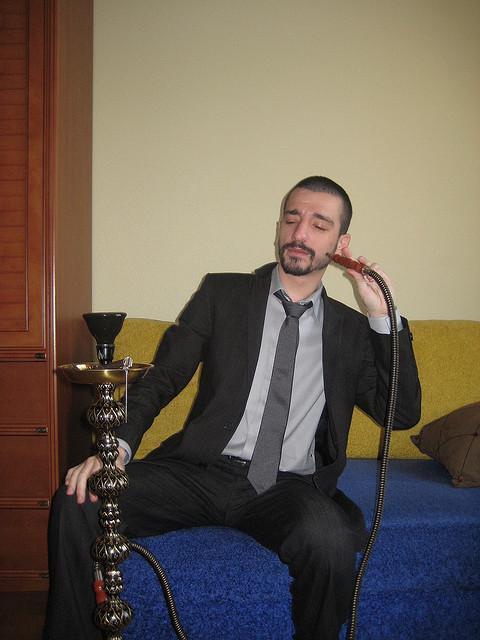What comes through the pipe held here?
Choose the right answer and clarify with the format: 'Answer: answer
Rationale: rationale.'
Options: Smoke, cookies, milk, oil. Answer: smoke.
Rationale: The pipe has smoke. 